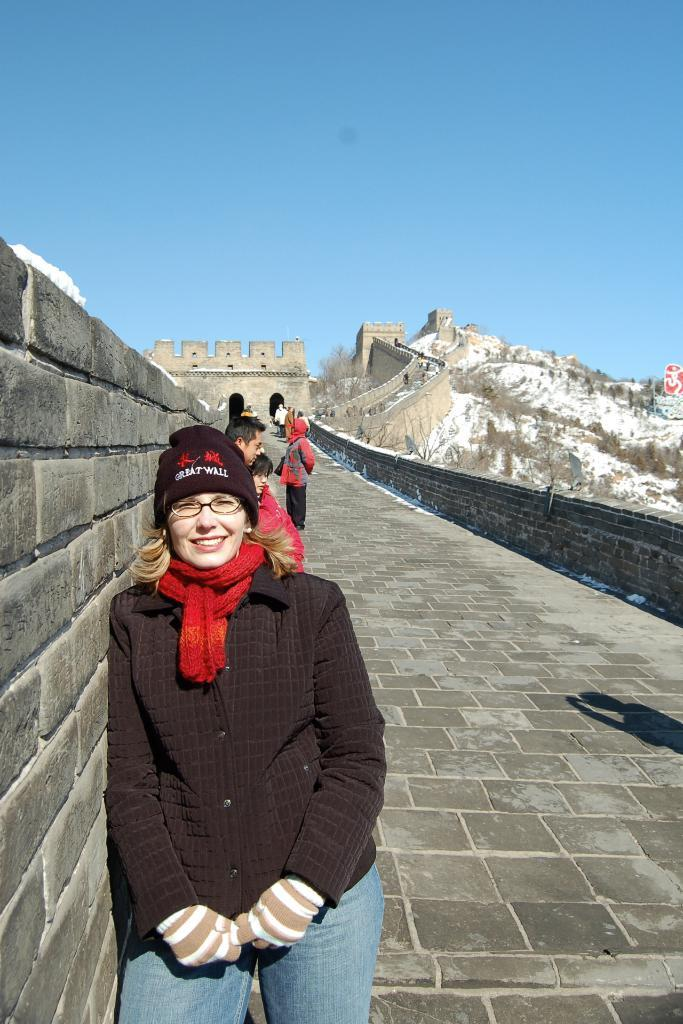What is happening on the road in the image? There are persons on the road in the image. Can you describe one of the persons in the image? One person is wearing spectacles and smiling. What can be seen in the background of the image? The sky is visible in the background of the image. What structures are present in the image? There is a wall, a fort, and a board in the image. What type of silk is being sold on the board in the image? There is no silk or any indication of a sale in the image; the board is not related to silk or any other product. 